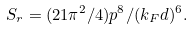Convert formula to latex. <formula><loc_0><loc_0><loc_500><loc_500>S _ { r } = ( 2 1 \pi ^ { 2 } / 4 ) p ^ { 8 } / ( k _ { F } d ) ^ { 6 } .</formula> 